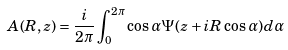Convert formula to latex. <formula><loc_0><loc_0><loc_500><loc_500>A ( R , z ) = \frac { i } { 2 \pi } \int ^ { 2 \pi } _ { 0 } \cos \alpha \Psi ( z + i R \cos \alpha ) d \alpha</formula> 